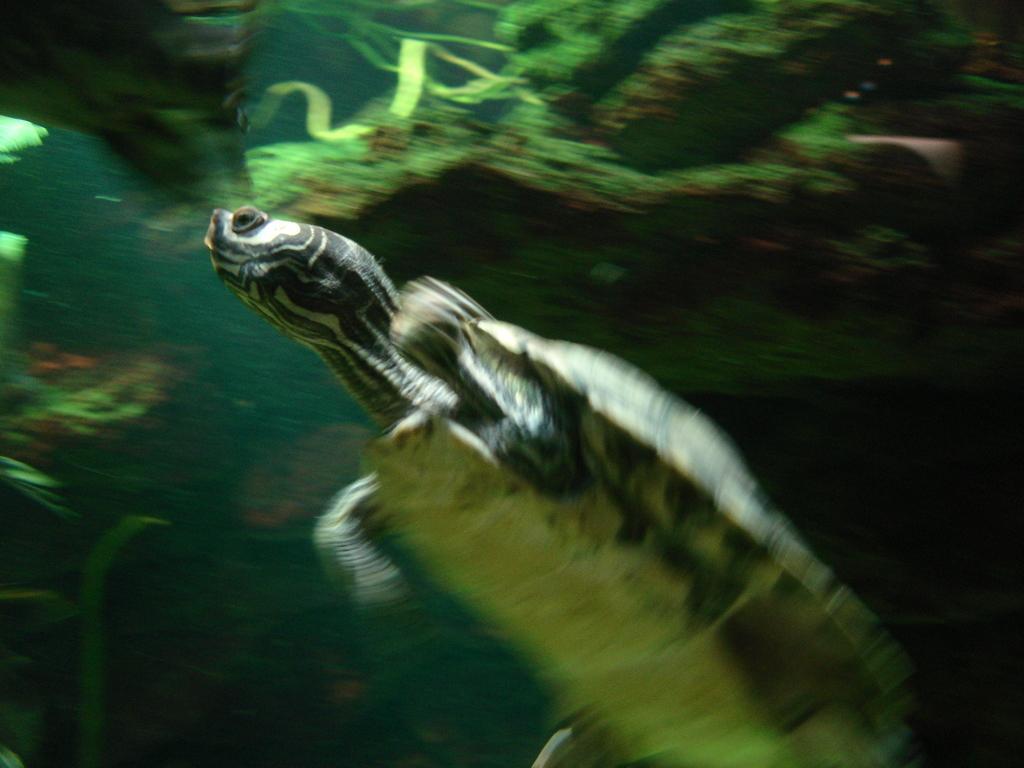Describe this image in one or two sentences. This picture is slightly blurred, where I can see a tortoise is swimming in the water and in the background, I can see the marine plants. 